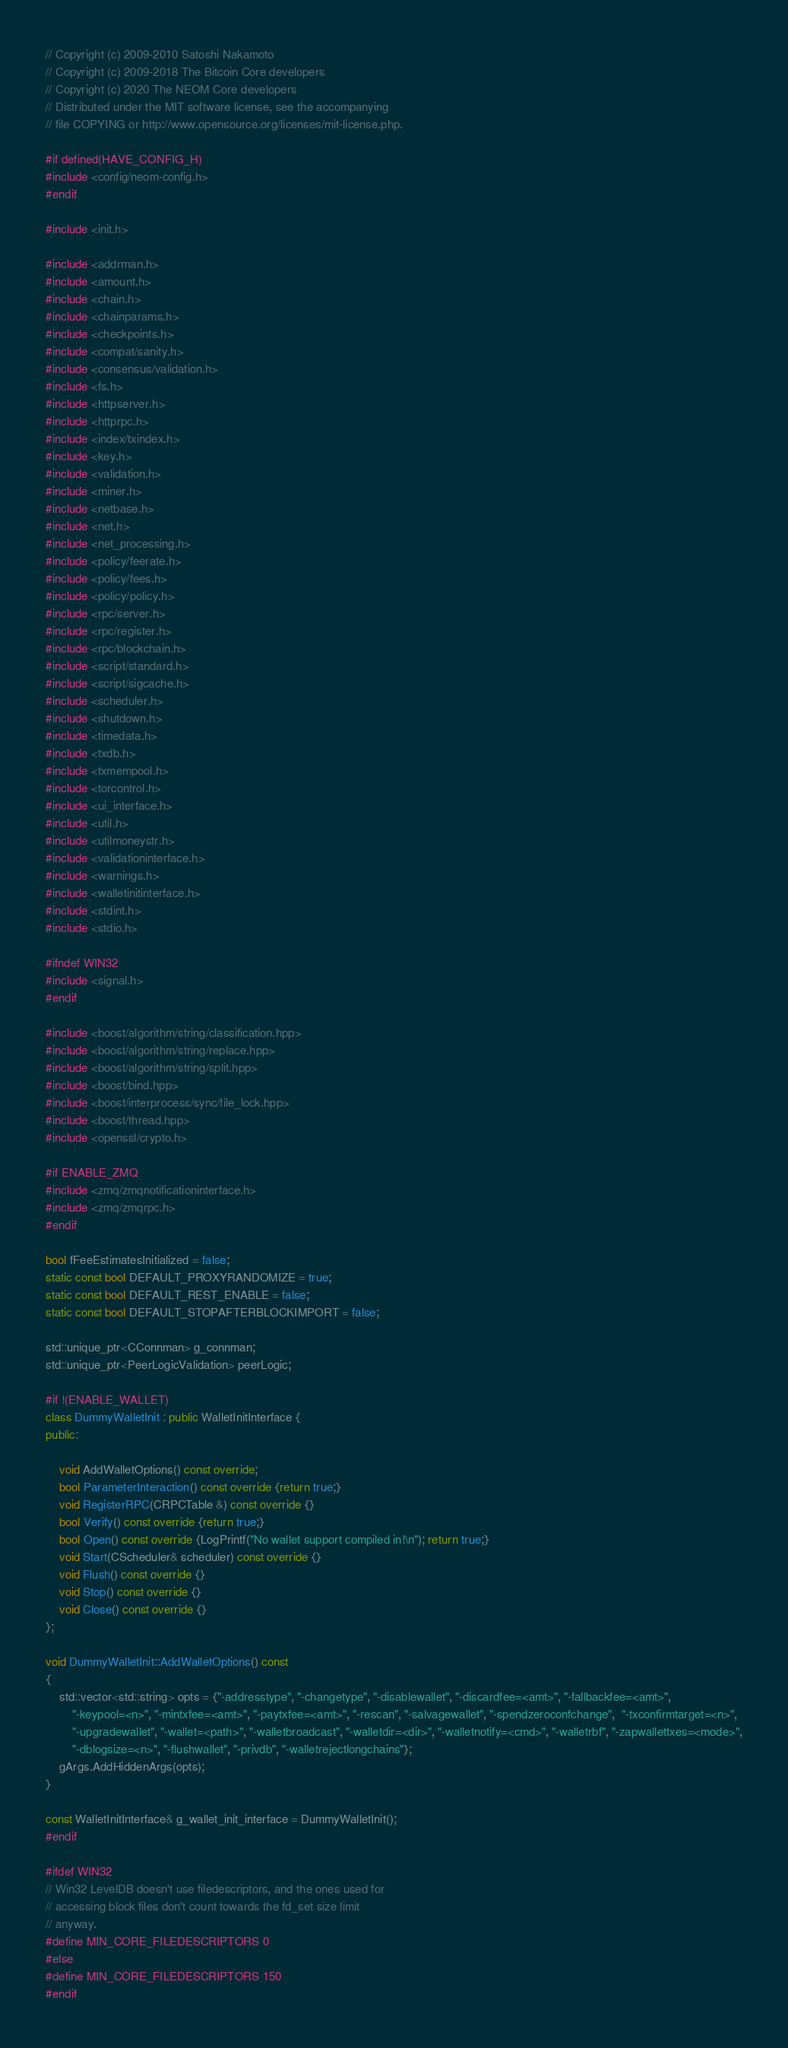Convert code to text. <code><loc_0><loc_0><loc_500><loc_500><_C++_>// Copyright (c) 2009-2010 Satoshi Nakamoto
// Copyright (c) 2009-2018 The Bitcoin Core developers
// Copyright (c) 2020 The NEOM Core developers
// Distributed under the MIT software license, see the accompanying
// file COPYING or http://www.opensource.org/licenses/mit-license.php.

#if defined(HAVE_CONFIG_H)
#include <config/neom-config.h>
#endif

#include <init.h>

#include <addrman.h>
#include <amount.h>
#include <chain.h>
#include <chainparams.h>
#include <checkpoints.h>
#include <compat/sanity.h>
#include <consensus/validation.h>
#include <fs.h>
#include <httpserver.h>
#include <httprpc.h>
#include <index/txindex.h>
#include <key.h>
#include <validation.h>
#include <miner.h>
#include <netbase.h>
#include <net.h>
#include <net_processing.h>
#include <policy/feerate.h>
#include <policy/fees.h>
#include <policy/policy.h>
#include <rpc/server.h>
#include <rpc/register.h>
#include <rpc/blockchain.h>
#include <script/standard.h>
#include <script/sigcache.h>
#include <scheduler.h>
#include <shutdown.h>
#include <timedata.h>
#include <txdb.h>
#include <txmempool.h>
#include <torcontrol.h>
#include <ui_interface.h>
#include <util.h>
#include <utilmoneystr.h>
#include <validationinterface.h>
#include <warnings.h>
#include <walletinitinterface.h>
#include <stdint.h>
#include <stdio.h>

#ifndef WIN32
#include <signal.h>
#endif

#include <boost/algorithm/string/classification.hpp>
#include <boost/algorithm/string/replace.hpp>
#include <boost/algorithm/string/split.hpp>
#include <boost/bind.hpp>
#include <boost/interprocess/sync/file_lock.hpp>
#include <boost/thread.hpp>
#include <openssl/crypto.h>

#if ENABLE_ZMQ
#include <zmq/zmqnotificationinterface.h>
#include <zmq/zmqrpc.h>
#endif

bool fFeeEstimatesInitialized = false;
static const bool DEFAULT_PROXYRANDOMIZE = true;
static const bool DEFAULT_REST_ENABLE = false;
static const bool DEFAULT_STOPAFTERBLOCKIMPORT = false;

std::unique_ptr<CConnman> g_connman;
std::unique_ptr<PeerLogicValidation> peerLogic;

#if !(ENABLE_WALLET)
class DummyWalletInit : public WalletInitInterface {
public:

    void AddWalletOptions() const override;
    bool ParameterInteraction() const override {return true;}
    void RegisterRPC(CRPCTable &) const override {}
    bool Verify() const override {return true;}
    bool Open() const override {LogPrintf("No wallet support compiled in!\n"); return true;}
    void Start(CScheduler& scheduler) const override {}
    void Flush() const override {}
    void Stop() const override {}
    void Close() const override {}
};

void DummyWalletInit::AddWalletOptions() const
{
    std::vector<std::string> opts = {"-addresstype", "-changetype", "-disablewallet", "-discardfee=<amt>", "-fallbackfee=<amt>",
        "-keypool=<n>", "-mintxfee=<amt>", "-paytxfee=<amt>", "-rescan", "-salvagewallet", "-spendzeroconfchange",  "-txconfirmtarget=<n>",
        "-upgradewallet", "-wallet=<path>", "-walletbroadcast", "-walletdir=<dir>", "-walletnotify=<cmd>", "-walletrbf", "-zapwallettxes=<mode>",
        "-dblogsize=<n>", "-flushwallet", "-privdb", "-walletrejectlongchains"};
    gArgs.AddHiddenArgs(opts);
}

const WalletInitInterface& g_wallet_init_interface = DummyWalletInit();
#endif

#ifdef WIN32
// Win32 LevelDB doesn't use filedescriptors, and the ones used for
// accessing block files don't count towards the fd_set size limit
// anyway.
#define MIN_CORE_FILEDESCRIPTORS 0
#else
#define MIN_CORE_FILEDESCRIPTORS 150
#endif
</code> 